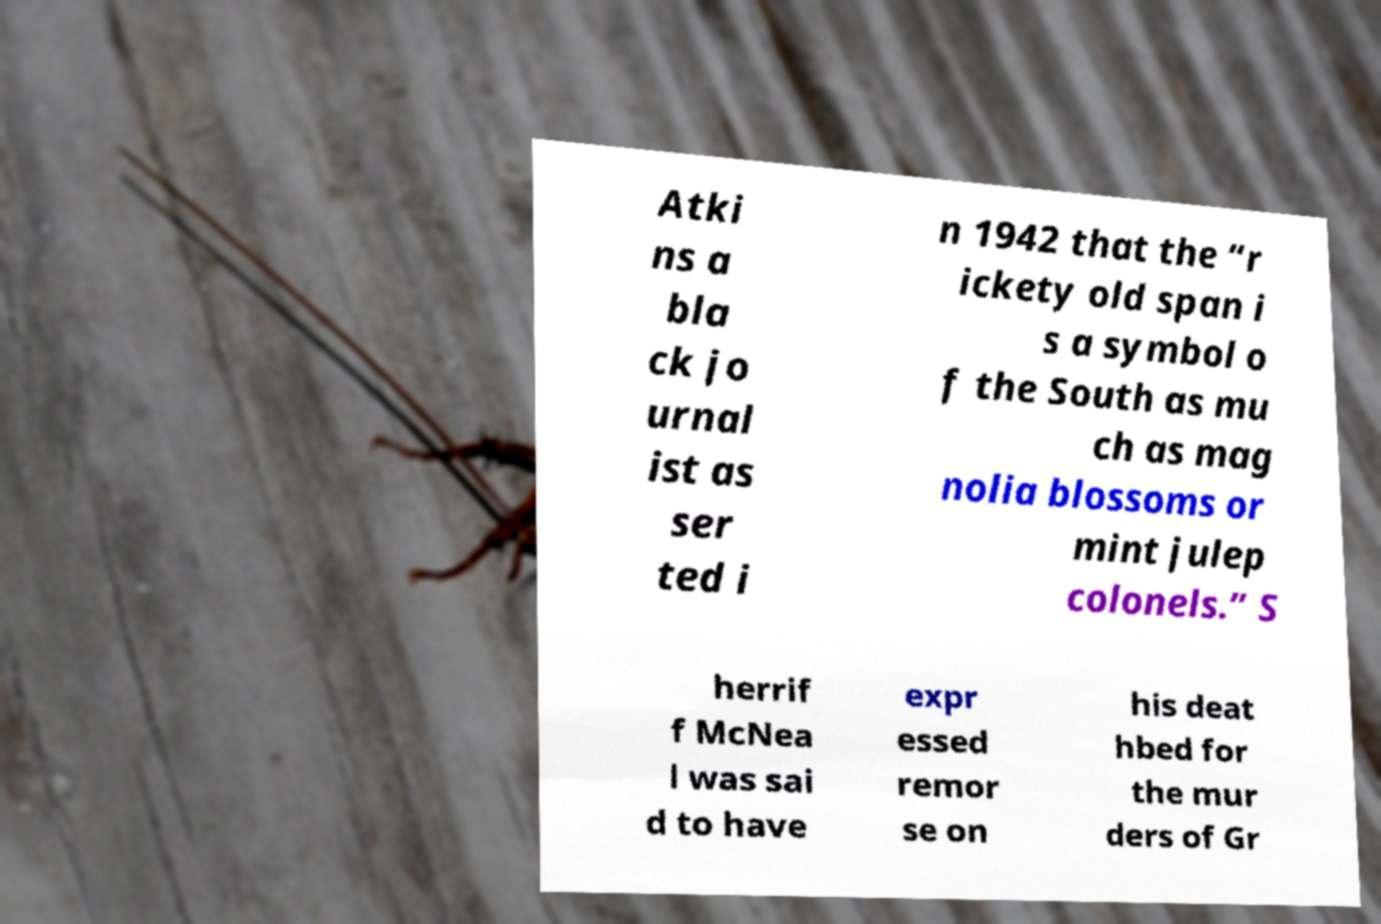Could you assist in decoding the text presented in this image and type it out clearly? Atki ns a bla ck jo urnal ist as ser ted i n 1942 that the “r ickety old span i s a symbol o f the South as mu ch as mag nolia blossoms or mint julep colonels.” S herrif f McNea l was sai d to have expr essed remor se on his deat hbed for the mur ders of Gr 